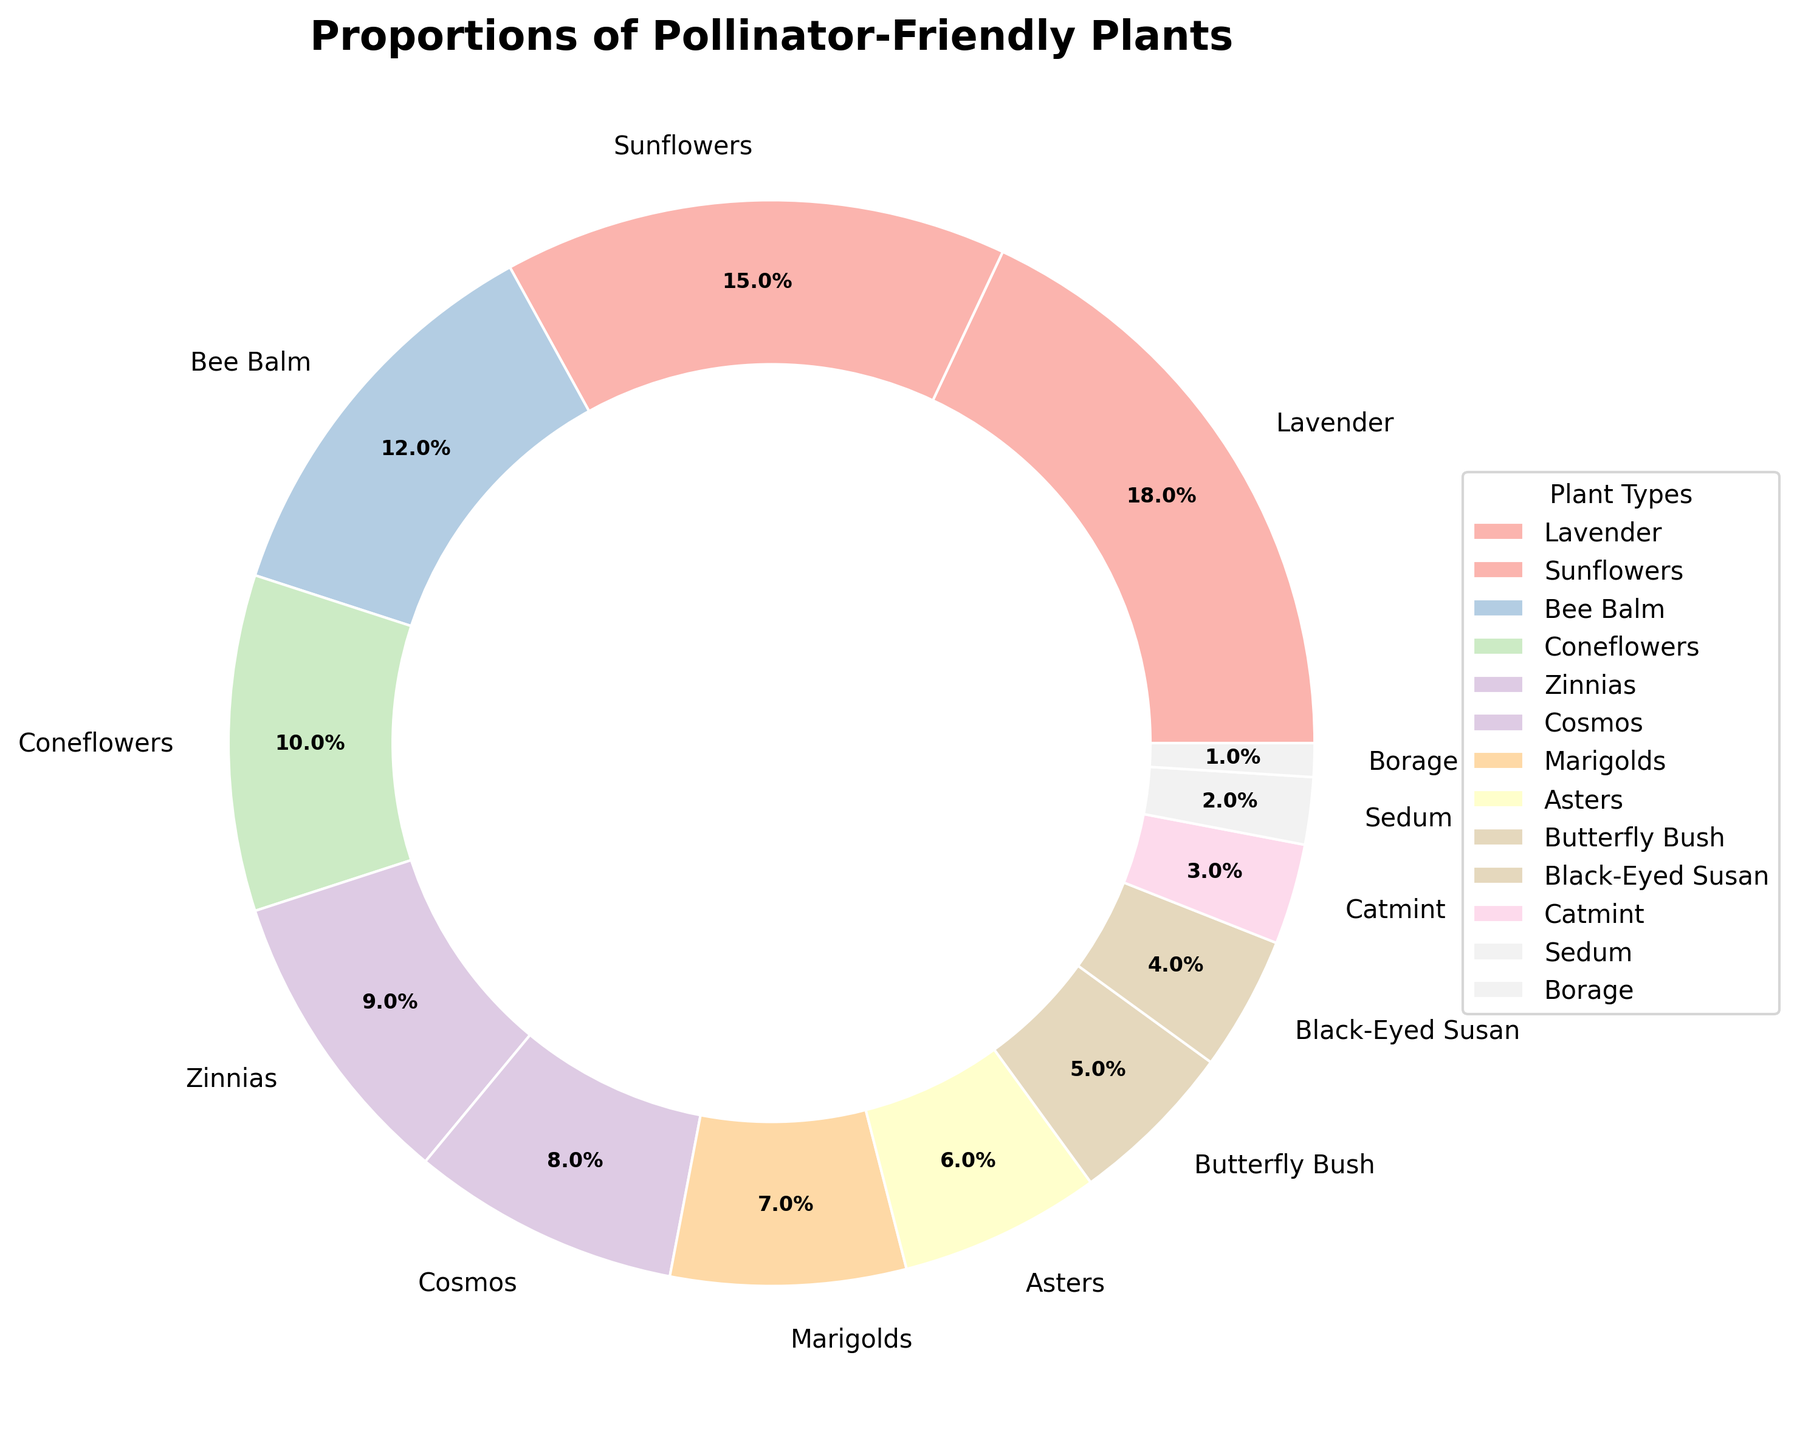Which plant type occupies the largest proportion of the garden? By looking at the pie chart, identify the plant type with the largest wedge. The label corresponding to this wedge will indicate the plant type with the largest proportion.
Answer: Lavender Which two plant types together constitute more than 30% of the garden? Identify the plant types with the highest percentages and sum them up. The two highest proportions are Lavender (18%) and Sunflowers (15%). Adding these gives 18% + 15% = 33%, which is more than 30%.
Answer: Lavender and Sunflowers How does the proportion of Bee Balm compare to that of Zinnias? Compare the percentage values for Bee Balm and Zinnias indicated on the pie chart. Bee Balm has 12% and Zinnias have 9%.
Answer: Bee Balm has a higher proportion than Zinnias Which plant type has an approximate proportion of 10% in the garden? Identify the plant type with a percentage closest to 10% on the pie chart.
Answer: Coneflowers Between Marigolds and Cosmos, which has the smaller proportion? Compare the percentage values for Marigolds and Cosmos. Marigolds have 7% while Cosmos have 8%.
Answer: Marigolds What is the combined percentage of the plants that individually have less than 5% proportion? Identify the plant types with percentages less than 5% (Butterfly Bush, Black-Eyed Susan, Catmint, Sedum, Borage), then sum their percentages: 5% + 4% + 3% + 2% + 1% = 15%.
Answer: 15% If you had to remove one type of plant to make space for a new type, which plant type would be the least impactful according to the chart? Identify the plant type with the smallest wedge or percentage on the pie chart.
Answer: Borage Arrange the following plants in descending order of their proportions: Cosmos, Bee Balm, Catmint. Refer to the pie chart to get the exact proportions of each plant type. Cosmos is 8%, Bee Balm is 12%, and Catmint is 3%. In descending order: Bee Balm, Cosmos, Catmint.
Answer: Bee Balm, Cosmos, Catmint 